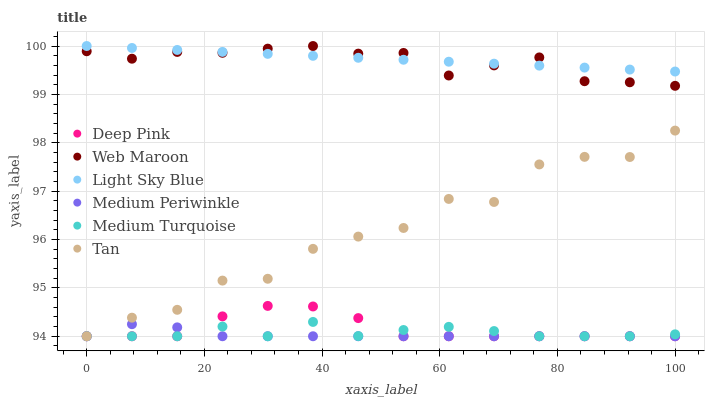Does Medium Periwinkle have the minimum area under the curve?
Answer yes or no. Yes. Does Light Sky Blue have the maximum area under the curve?
Answer yes or no. Yes. Does Web Maroon have the minimum area under the curve?
Answer yes or no. No. Does Web Maroon have the maximum area under the curve?
Answer yes or no. No. Is Light Sky Blue the smoothest?
Answer yes or no. Yes. Is Tan the roughest?
Answer yes or no. Yes. Is Web Maroon the smoothest?
Answer yes or no. No. Is Web Maroon the roughest?
Answer yes or no. No. Does Deep Pink have the lowest value?
Answer yes or no. Yes. Does Web Maroon have the lowest value?
Answer yes or no. No. Does Light Sky Blue have the highest value?
Answer yes or no. Yes. Does Medium Periwinkle have the highest value?
Answer yes or no. No. Is Medium Periwinkle less than Light Sky Blue?
Answer yes or no. Yes. Is Web Maroon greater than Medium Turquoise?
Answer yes or no. Yes. Does Medium Periwinkle intersect Deep Pink?
Answer yes or no. Yes. Is Medium Periwinkle less than Deep Pink?
Answer yes or no. No. Is Medium Periwinkle greater than Deep Pink?
Answer yes or no. No. Does Medium Periwinkle intersect Light Sky Blue?
Answer yes or no. No. 